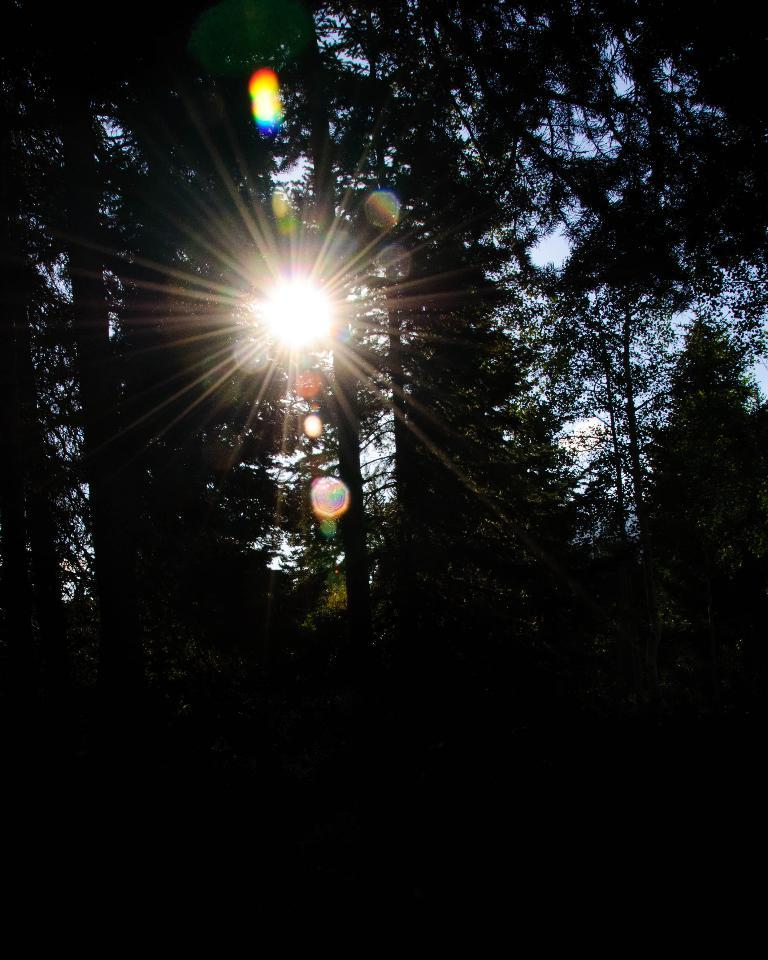What can be seen in the dark area of the image? Trees are visible in the dark area of the image. Can you describe the position of the sun in the image? The sun is visible in the image. What is visible in the background of the image? The sky is visible in the background of the image. What type of government can be seen in the image? There is no reference to a government in the image, as it features a dark area with trees and a visible sun and sky. 